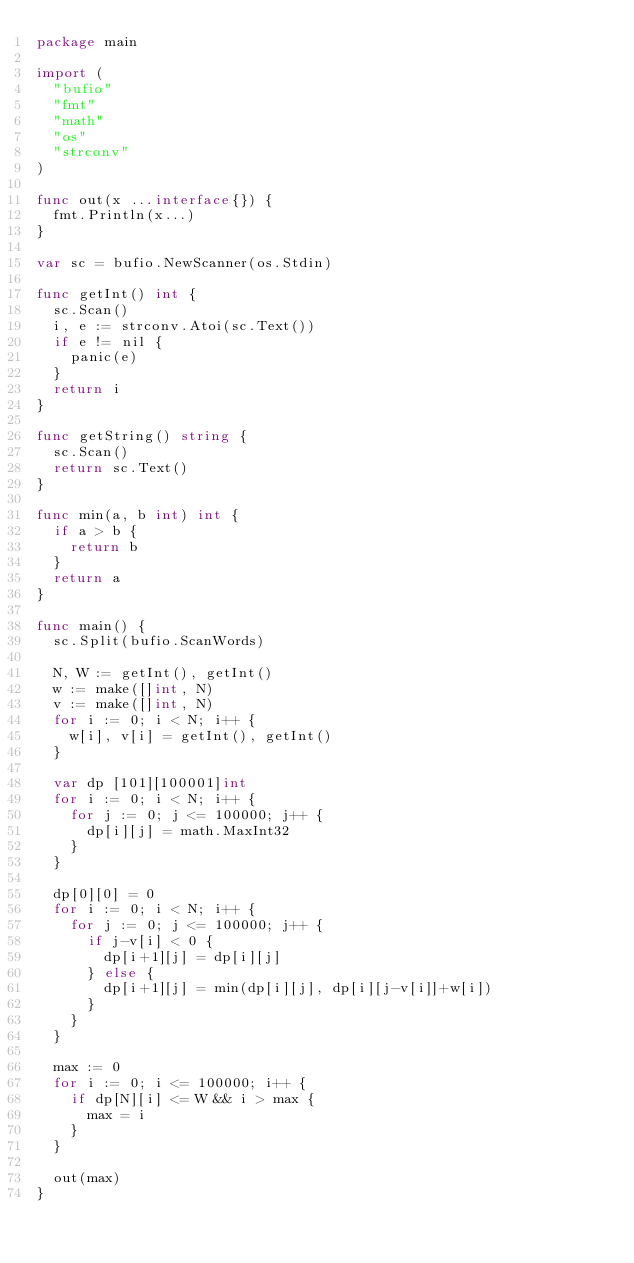Convert code to text. <code><loc_0><loc_0><loc_500><loc_500><_Go_>package main

import (
	"bufio"
	"fmt"
	"math"
	"os"
	"strconv"
)

func out(x ...interface{}) {
	fmt.Println(x...)
}

var sc = bufio.NewScanner(os.Stdin)

func getInt() int {
	sc.Scan()
	i, e := strconv.Atoi(sc.Text())
	if e != nil {
		panic(e)
	}
	return i
}

func getString() string {
	sc.Scan()
	return sc.Text()
}

func min(a, b int) int {
	if a > b {
		return b
	}
	return a
}

func main() {
	sc.Split(bufio.ScanWords)

	N, W := getInt(), getInt()
	w := make([]int, N)
	v := make([]int, N)
	for i := 0; i < N; i++ {
		w[i], v[i] = getInt(), getInt()
	}

	var dp [101][100001]int
	for i := 0; i < N; i++ {
		for j := 0; j <= 100000; j++ {
			dp[i][j] = math.MaxInt32
		}
	}

	dp[0][0] = 0
	for i := 0; i < N; i++ {
		for j := 0; j <= 100000; j++ {
			if j-v[i] < 0 {
				dp[i+1][j] = dp[i][j]
			} else {
				dp[i+1][j] = min(dp[i][j], dp[i][j-v[i]]+w[i])
			}
		}
	}

	max := 0
	for i := 0; i <= 100000; i++ {
		if dp[N][i] <= W && i > max {
			max = i
		}
	}

	out(max)
}
</code> 